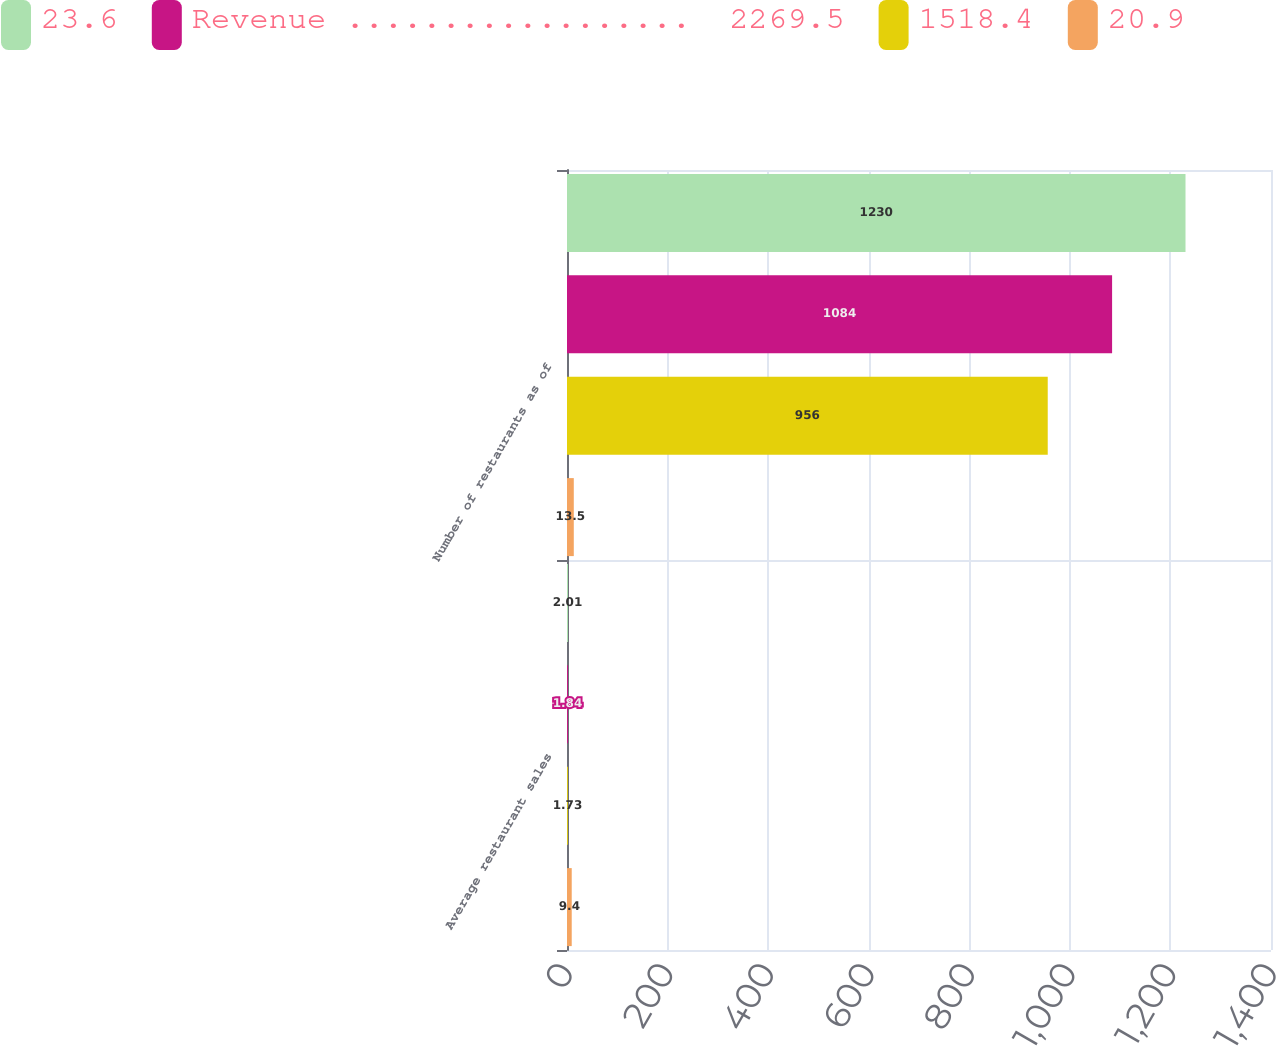Convert chart to OTSL. <chart><loc_0><loc_0><loc_500><loc_500><stacked_bar_chart><ecel><fcel>Average restaurant sales<fcel>Number of restaurants as of<nl><fcel>23.6<fcel>2.01<fcel>1230<nl><fcel>Revenue ..................  2269.5<fcel>1.84<fcel>1084<nl><fcel>1518.4<fcel>1.73<fcel>956<nl><fcel>20.9<fcel>9.4<fcel>13.5<nl></chart> 